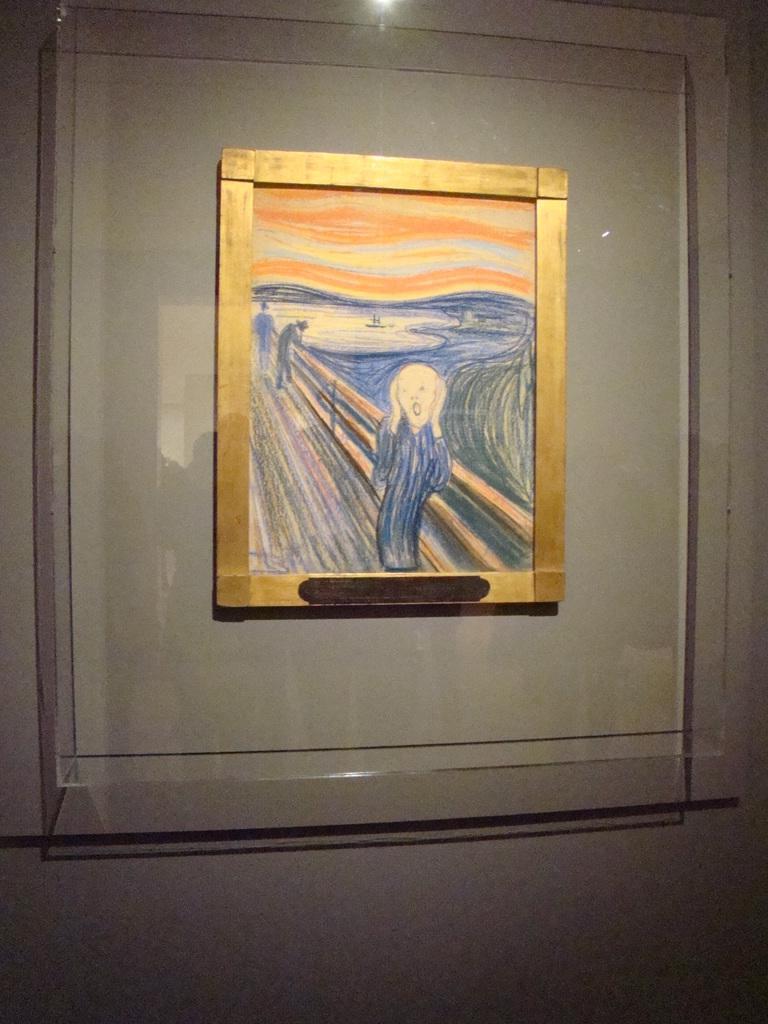In one or two sentences, can you explain what this image depicts? This picture we can observe yellow color frame fixed to the wall. In this frame we can observe a sketch of two persons near the railing. This frame was placed behind the glass door. 